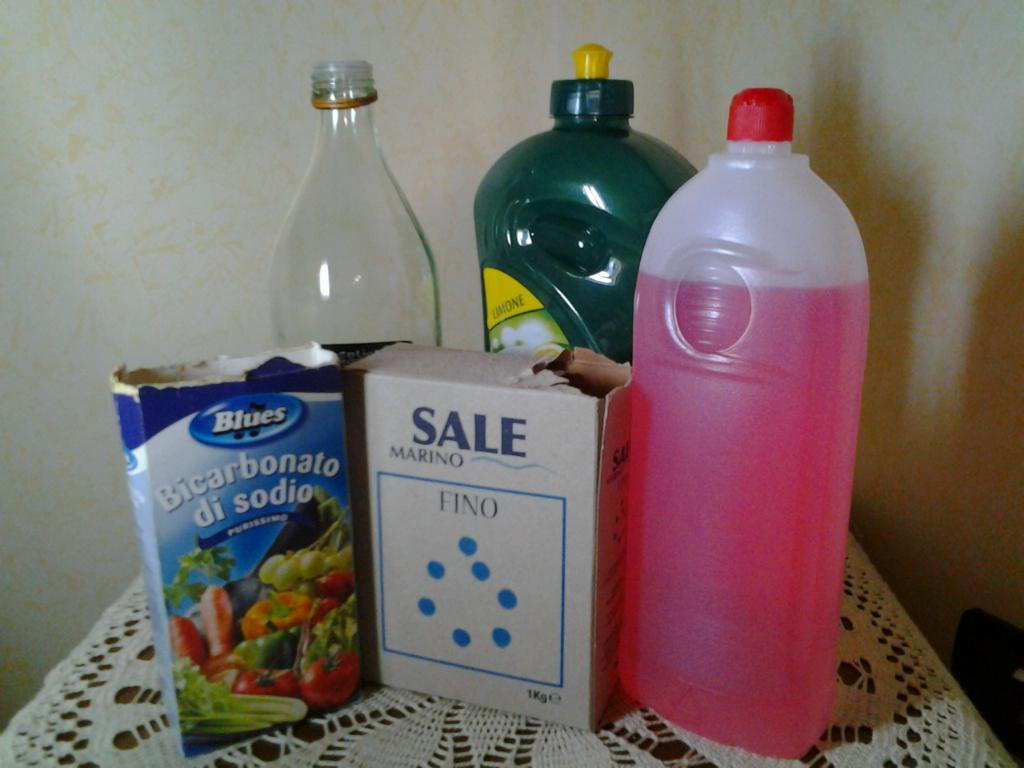<image>
Give a short and clear explanation of the subsequent image. A box of Fino and a box of Bicarbonato di sodio are in front of three bottles. 